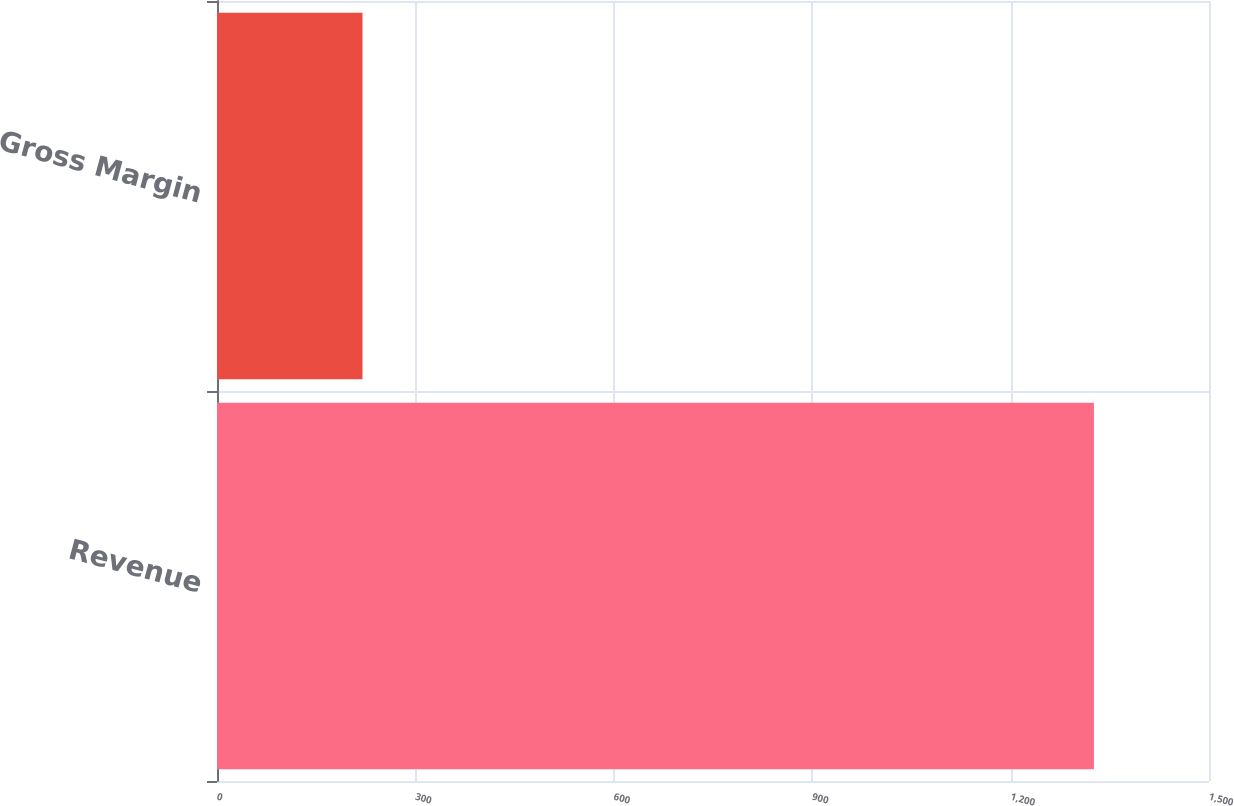Convert chart. <chart><loc_0><loc_0><loc_500><loc_500><bar_chart><fcel>Revenue<fcel>Gross Margin<nl><fcel>1326<fcel>220<nl></chart> 